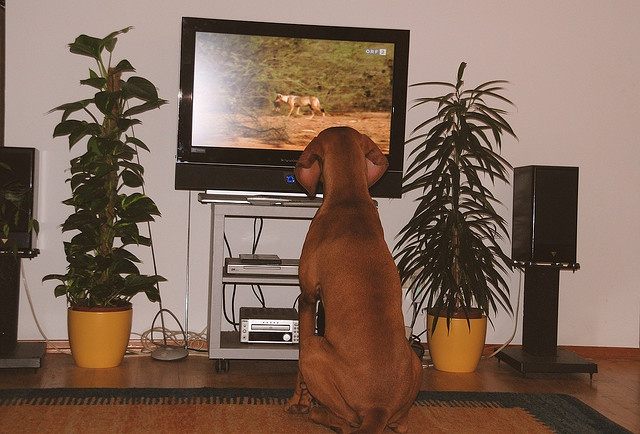Describe the objects in this image and their specific colors. I can see tv in black, olive, lightgray, and gray tones, dog in black, maroon, and brown tones, potted plant in black, darkgray, orange, and maroon tones, potted plant in black, red, darkgray, and maroon tones, and dog in black, brown, and tan tones in this image. 